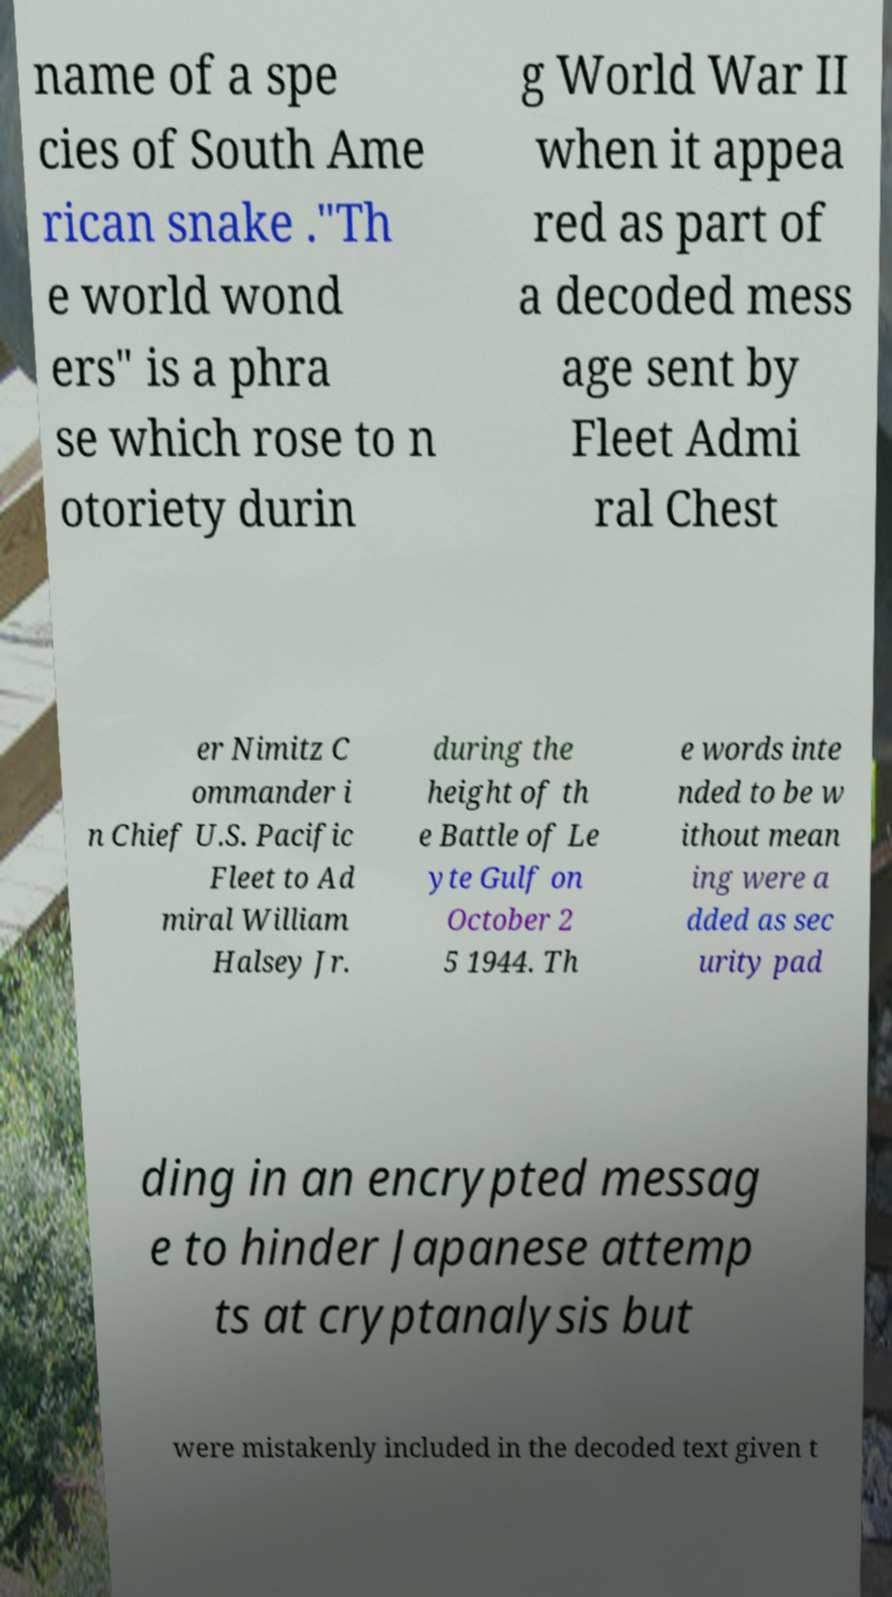Could you assist in decoding the text presented in this image and type it out clearly? name of a spe cies of South Ame rican snake ."Th e world wond ers" is a phra se which rose to n otoriety durin g World War II when it appea red as part of a decoded mess age sent by Fleet Admi ral Chest er Nimitz C ommander i n Chief U.S. Pacific Fleet to Ad miral William Halsey Jr. during the height of th e Battle of Le yte Gulf on October 2 5 1944. Th e words inte nded to be w ithout mean ing were a dded as sec urity pad ding in an encrypted messag e to hinder Japanese attemp ts at cryptanalysis but were mistakenly included in the decoded text given t 